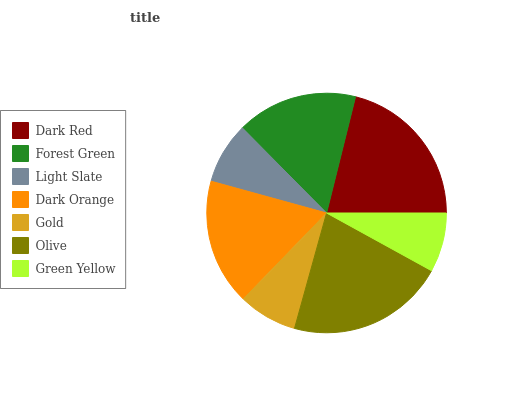Is Gold the minimum?
Answer yes or no. Yes. Is Olive the maximum?
Answer yes or no. Yes. Is Forest Green the minimum?
Answer yes or no. No. Is Forest Green the maximum?
Answer yes or no. No. Is Dark Red greater than Forest Green?
Answer yes or no. Yes. Is Forest Green less than Dark Red?
Answer yes or no. Yes. Is Forest Green greater than Dark Red?
Answer yes or no. No. Is Dark Red less than Forest Green?
Answer yes or no. No. Is Forest Green the high median?
Answer yes or no. Yes. Is Forest Green the low median?
Answer yes or no. Yes. Is Dark Orange the high median?
Answer yes or no. No. Is Dark Red the low median?
Answer yes or no. No. 